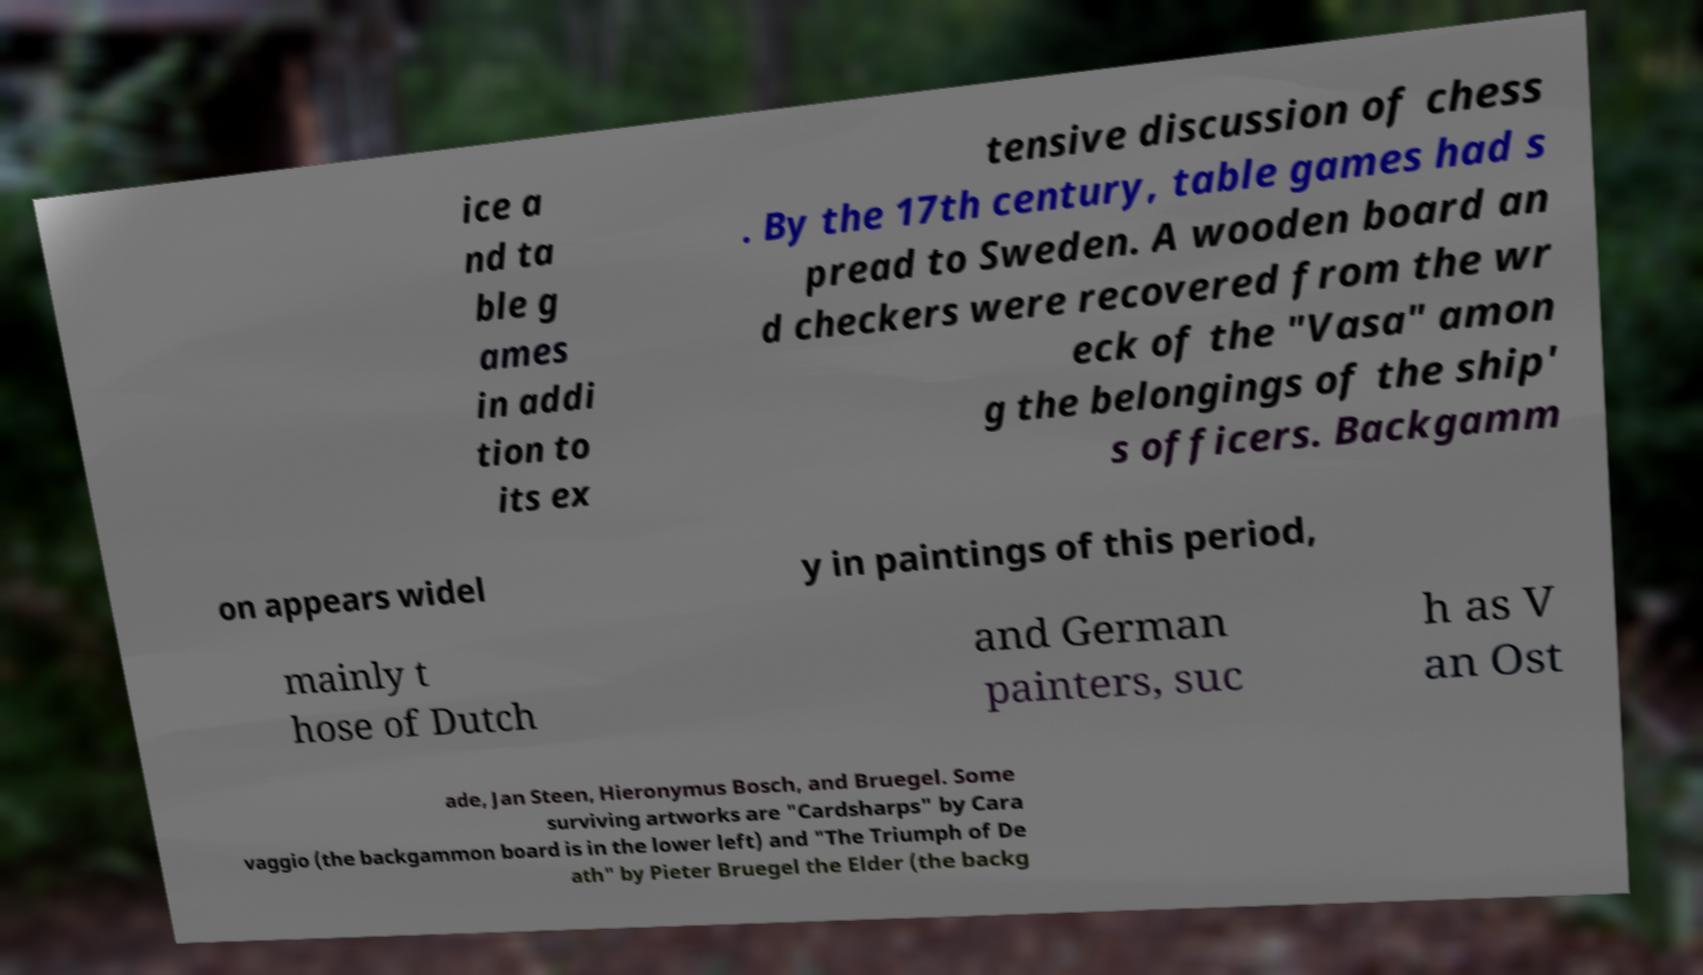There's text embedded in this image that I need extracted. Can you transcribe it verbatim? ice a nd ta ble g ames in addi tion to its ex tensive discussion of chess . By the 17th century, table games had s pread to Sweden. A wooden board an d checkers were recovered from the wr eck of the "Vasa" amon g the belongings of the ship' s officers. Backgamm on appears widel y in paintings of this period, mainly t hose of Dutch and German painters, suc h as V an Ost ade, Jan Steen, Hieronymus Bosch, and Bruegel. Some surviving artworks are "Cardsharps" by Cara vaggio (the backgammon board is in the lower left) and "The Triumph of De ath" by Pieter Bruegel the Elder (the backg 